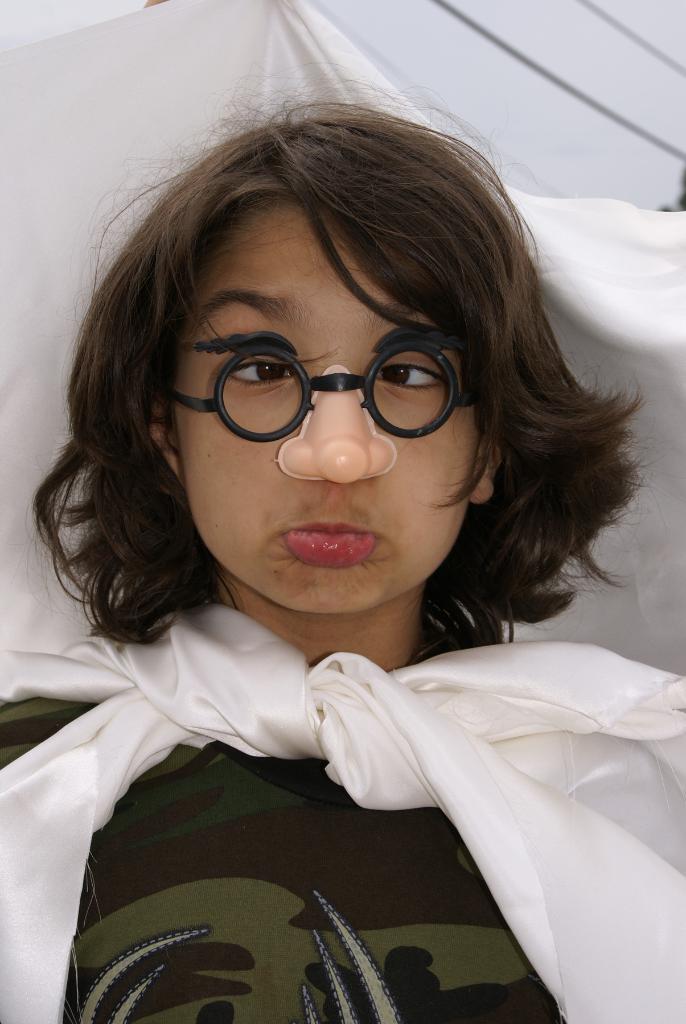Can you describe this image briefly? In this picture there is a person wore glasses, nose mask and white cloth. In the background of the image we can see wires and sky. 